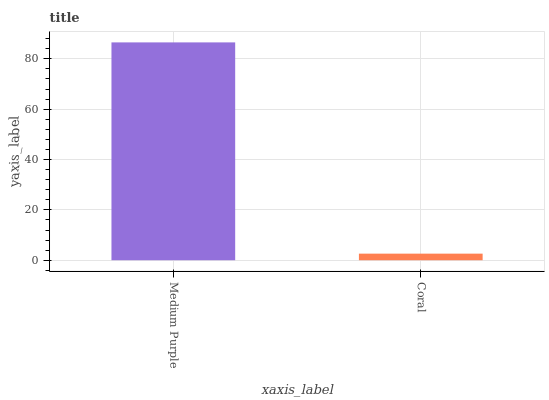Is Coral the maximum?
Answer yes or no. No. Is Medium Purple greater than Coral?
Answer yes or no. Yes. Is Coral less than Medium Purple?
Answer yes or no. Yes. Is Coral greater than Medium Purple?
Answer yes or no. No. Is Medium Purple less than Coral?
Answer yes or no. No. Is Medium Purple the high median?
Answer yes or no. Yes. Is Coral the low median?
Answer yes or no. Yes. Is Coral the high median?
Answer yes or no. No. Is Medium Purple the low median?
Answer yes or no. No. 